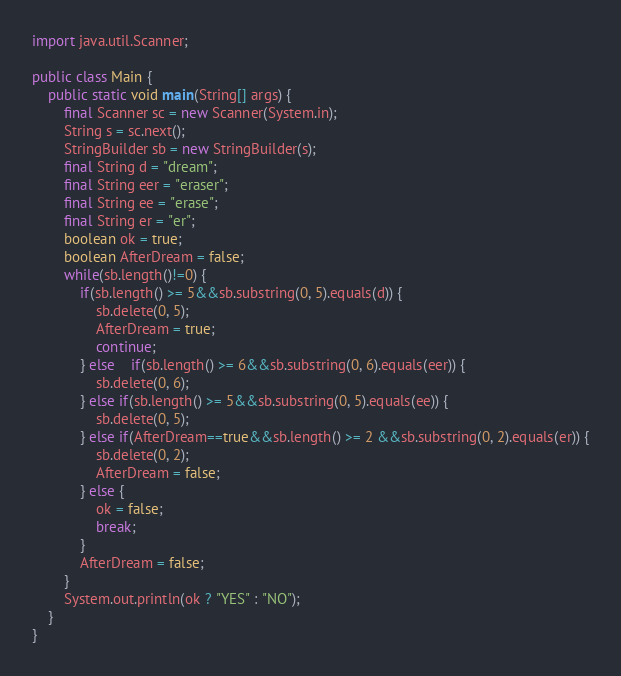<code> <loc_0><loc_0><loc_500><loc_500><_Java_>import java.util.Scanner;

public class Main {
	public static void main(String[] args) {
		final Scanner sc = new Scanner(System.in);
		String s = sc.next();
		StringBuilder sb = new StringBuilder(s);
		final String d = "dream";
		final String eer = "eraser";
		final String ee = "erase";
		final String er = "er";
		boolean ok = true;
		boolean AfterDream = false;
		while(sb.length()!=0) {
			if(sb.length() >= 5&&sb.substring(0, 5).equals(d)) {
				sb.delete(0, 5);
				AfterDream = true;
				continue;
			} else 	if(sb.length() >= 6&&sb.substring(0, 6).equals(eer)) {
				sb.delete(0, 6);
			} else if(sb.length() >= 5&&sb.substring(0, 5).equals(ee)) {
				sb.delete(0, 5);
			} else if(AfterDream==true&&sb.length() >= 2 &&sb.substring(0, 2).equals(er)) {
				sb.delete(0, 2);
				AfterDream = false;
			} else {
				ok = false;
				break;
			}
			AfterDream = false;
		}
		System.out.println(ok ? "YES" : "NO");
	}
}</code> 